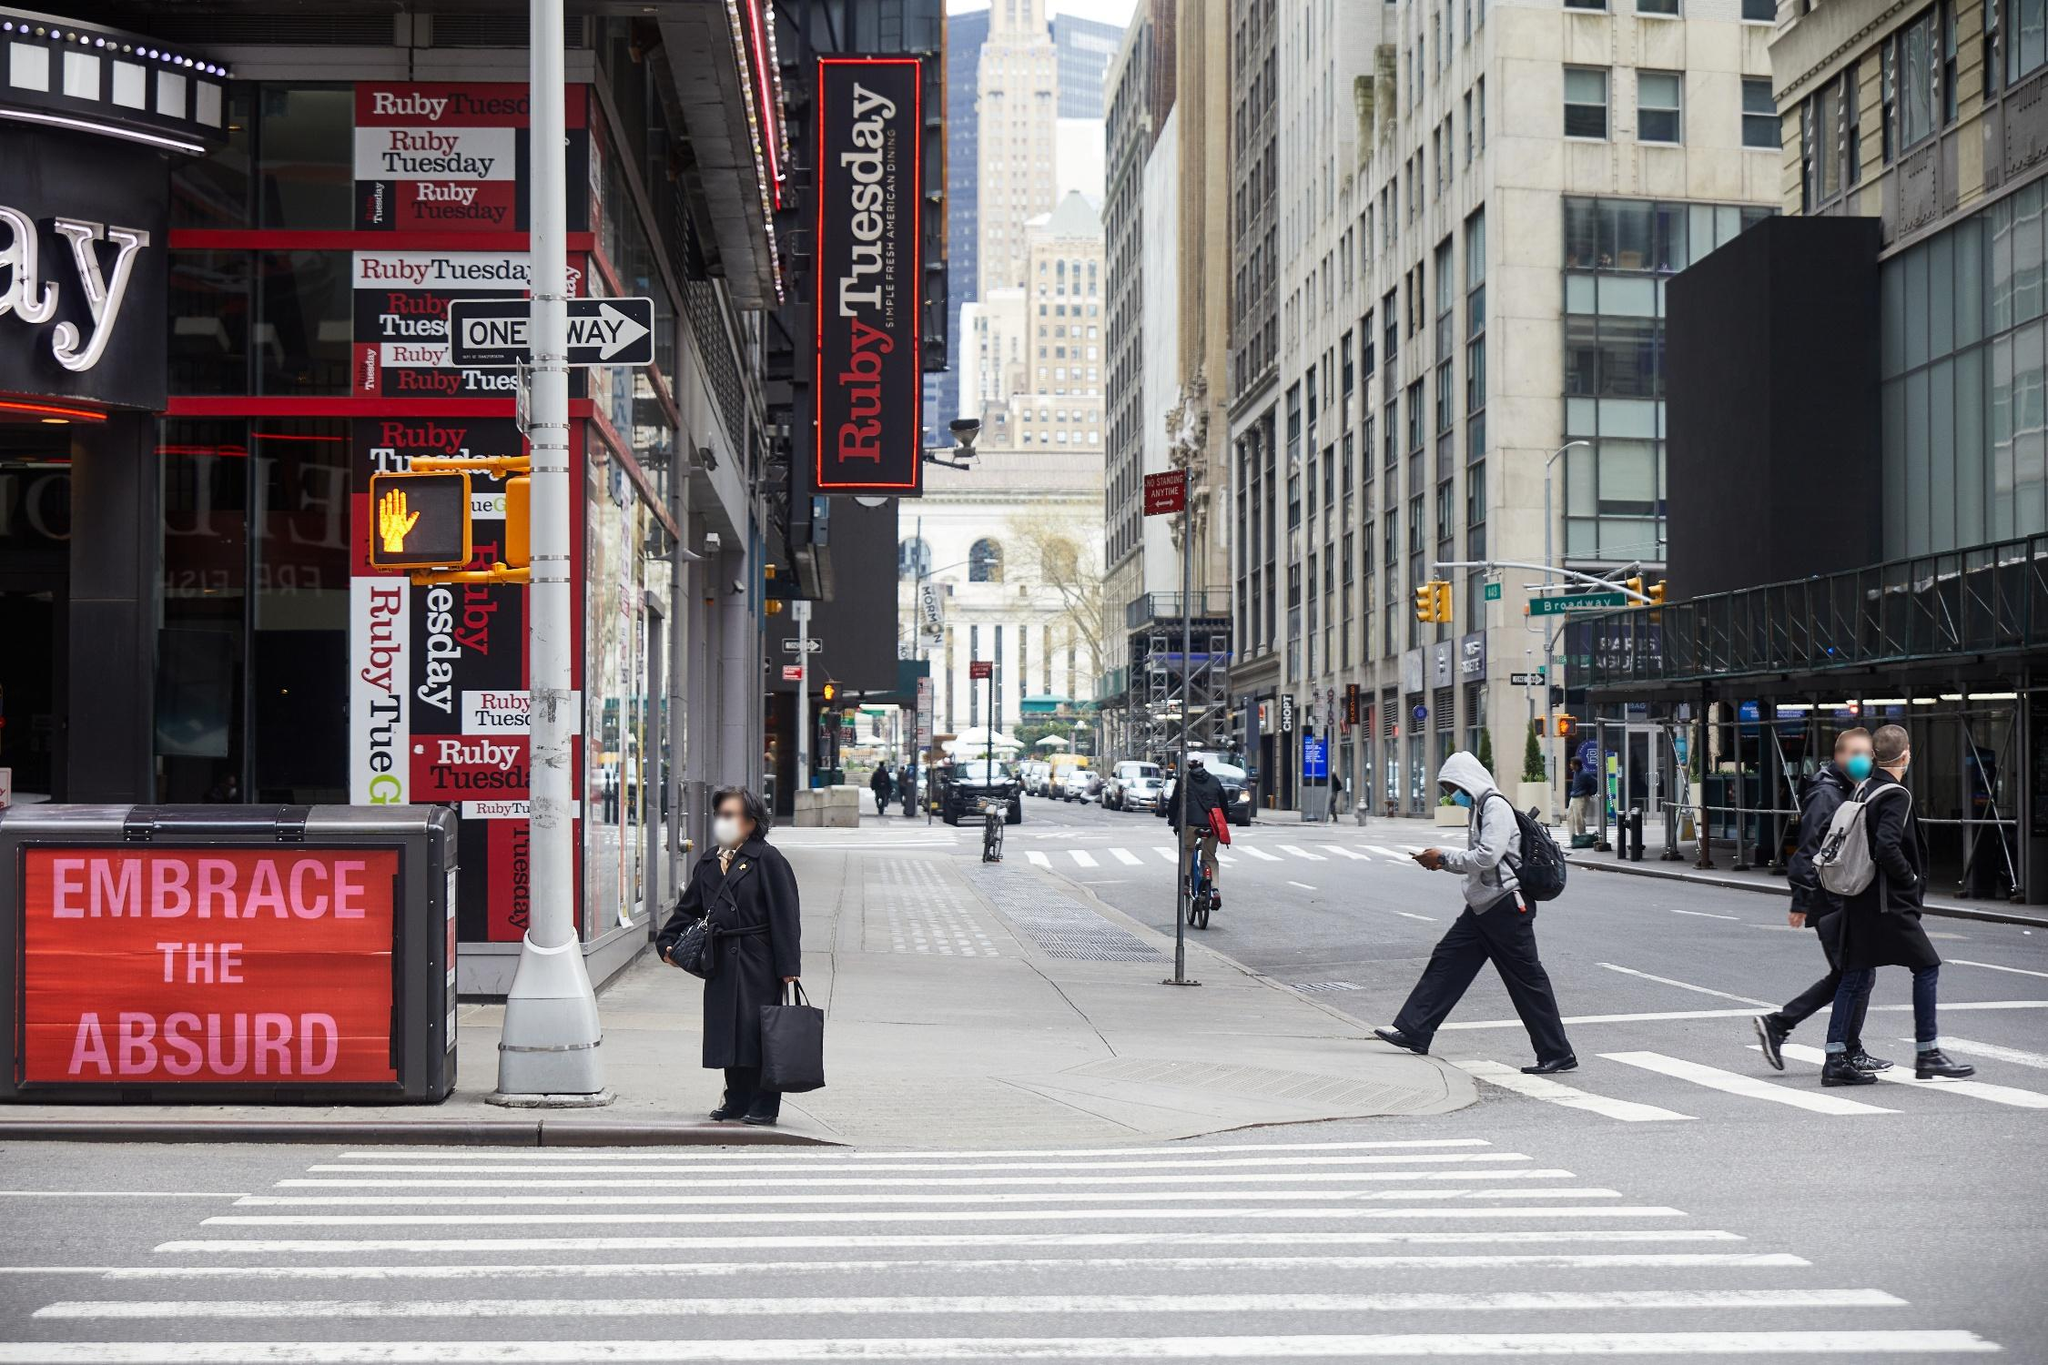What could be the impact of weather on this scene? The overcast sky adds a subdued, calm vibe to the scene, softening the colors and creating a slightly melancholic atmosphere. It might make pedestrians move a bit quicker, in anticipation of potential rain. However, the city's energy remains strong, with individuals continuing their daily routines undeterred. If it were sunny, the scene might appear more vibrant and bustling; the brightness could bring out more colors in the environment, and pedestrians might appear more leisurely. Conversely, a rainy day would introduce umbrellas and perhaps a more hurried pace as people seek shelter, adding a sense of urgency to the scene. Can you describe the scene if it were a winter evening? On a winter evening, this New York City scene would transform entirely. The towering buildings would be dusted with a layer of fresh snow, and the sidewalks would be blanketed in white, slush accumulating at the edges as people trample through. Streetlights would cast a warm glow, reflecting off the snowy surfaces, creating a cozy, yet bustling evening ambiance. Pedestrians would be bundled in heavy coats, scarves, and hats, their breath visible in the cold air. The Ruby Tuesday sign would stand out even more vividly against the wintry backdrop, offering a welcoming respite from the chill. Softly, the iconic landmarks like the New York Public Library and the slightly visible Chrysler Building would be illuminated, their grandeur emphasized by the serene snowfall. The traffic lights and the occasional honk of a car would add to the overall magical yet chaotic feel of a winter evening in New York City. 